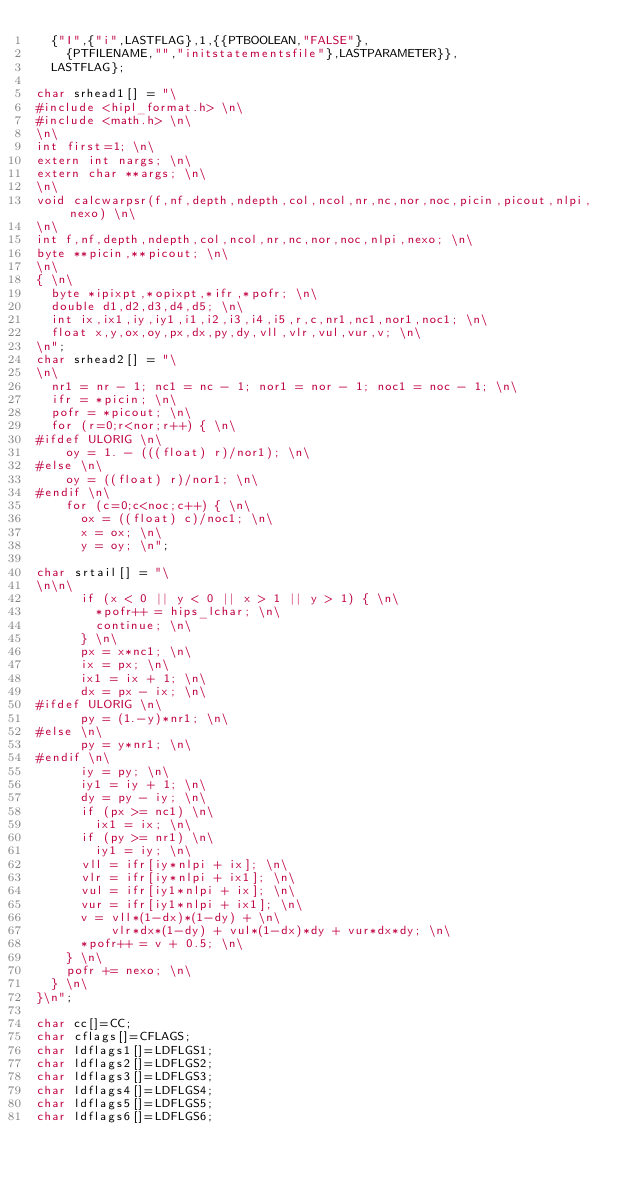Convert code to text. <code><loc_0><loc_0><loc_500><loc_500><_C_>	{"I",{"i",LASTFLAG},1,{{PTBOOLEAN,"FALSE"},
		{PTFILENAME,"","initstatementsfile"},LASTPARAMETER}},
	LASTFLAG};

char srhead1[] = "\
#include <hipl_format.h> \n\
#include <math.h> \n\
\n\
int first=1; \n\
extern int nargs; \n\
extern char **args; \n\
\n\
void calcwarpsr(f,nf,depth,ndepth,col,ncol,nr,nc,nor,noc,picin,picout,nlpi,nexo) \n\
\n\
int f,nf,depth,ndepth,col,ncol,nr,nc,nor,noc,nlpi,nexo; \n\
byte **picin,**picout; \n\
\n\
{ \n\
	byte *ipixpt,*opixpt,*ifr,*pofr; \n\
	double d1,d2,d3,d4,d5; \n\
	int ix,ix1,iy,iy1,i1,i2,i3,i4,i5,r,c,nr1,nc1,nor1,noc1; \n\
	float x,y,ox,oy,px,dx,py,dy,vll,vlr,vul,vur,v; \n\
\n";
char srhead2[] = "\
\n\
	nr1 = nr - 1; nc1 = nc - 1; nor1 = nor - 1; noc1 = noc - 1; \n\
	ifr = *picin; \n\
	pofr = *picout; \n\
	for (r=0;r<nor;r++) { \n\
#ifdef ULORIG \n\
		oy = 1. - (((float) r)/nor1); \n\
#else \n\
		oy = ((float) r)/nor1; \n\
#endif \n\
		for (c=0;c<noc;c++) { \n\
			ox = ((float) c)/noc1; \n\
			x = ox; \n\
			y = oy; \n";

char srtail[] = "\
\n\n\
			if (x < 0 || y < 0 || x > 1 || y > 1) { \n\
				*pofr++ = hips_lchar; \n\
				continue; \n\
			} \n\
			px = x*nc1; \n\
			ix = px; \n\
			ix1 = ix + 1; \n\
			dx = px - ix; \n\
#ifdef ULORIG \n\
			py = (1.-y)*nr1; \n\
#else \n\
			py = y*nr1; \n\
#endif \n\
			iy = py; \n\
			iy1 = iy + 1; \n\
			dy = py - iy; \n\
			if (px >= nc1) \n\
				ix1 = ix; \n\
			if (py >= nr1) \n\
				iy1 = iy; \n\
			vll = ifr[iy*nlpi + ix]; \n\
			vlr = ifr[iy*nlpi + ix1]; \n\
			vul = ifr[iy1*nlpi + ix]; \n\
			vur = ifr[iy1*nlpi + ix1]; \n\
			v = vll*(1-dx)*(1-dy) + \n\
			    vlr*dx*(1-dy) + vul*(1-dx)*dy + vur*dx*dy; \n\
			*pofr++ = v + 0.5; \n\
		} \n\
		pofr += nexo; \n\
	} \n\
}\n";

char cc[]=CC;
char cflags[]=CFLAGS;
char ldflags1[]=LDFLGS1;
char ldflags2[]=LDFLGS2;
char ldflags3[]=LDFLGS3;
char ldflags4[]=LDFLGS4;
char ldflags5[]=LDFLGS5;
char ldflags6[]=LDFLGS6;</code> 